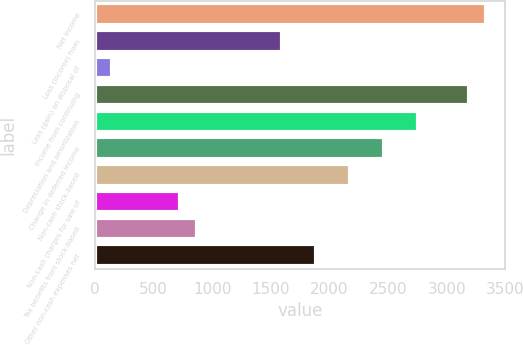Convert chart to OTSL. <chart><loc_0><loc_0><loc_500><loc_500><bar_chart><fcel>Net Income<fcel>Loss (income) from<fcel>Loss (gain) on disposal of<fcel>Income from continuing<fcel>Depreciation and amortization<fcel>Change in deferred income<fcel>Non-cash stock-based<fcel>Non-cash charges for sale of<fcel>Tax benefits from stock-based<fcel>Other non-cash expenses net<nl><fcel>3334.58<fcel>1595.06<fcel>145.46<fcel>3189.62<fcel>2754.74<fcel>2464.82<fcel>2174.9<fcel>725.3<fcel>870.26<fcel>1884.98<nl></chart> 